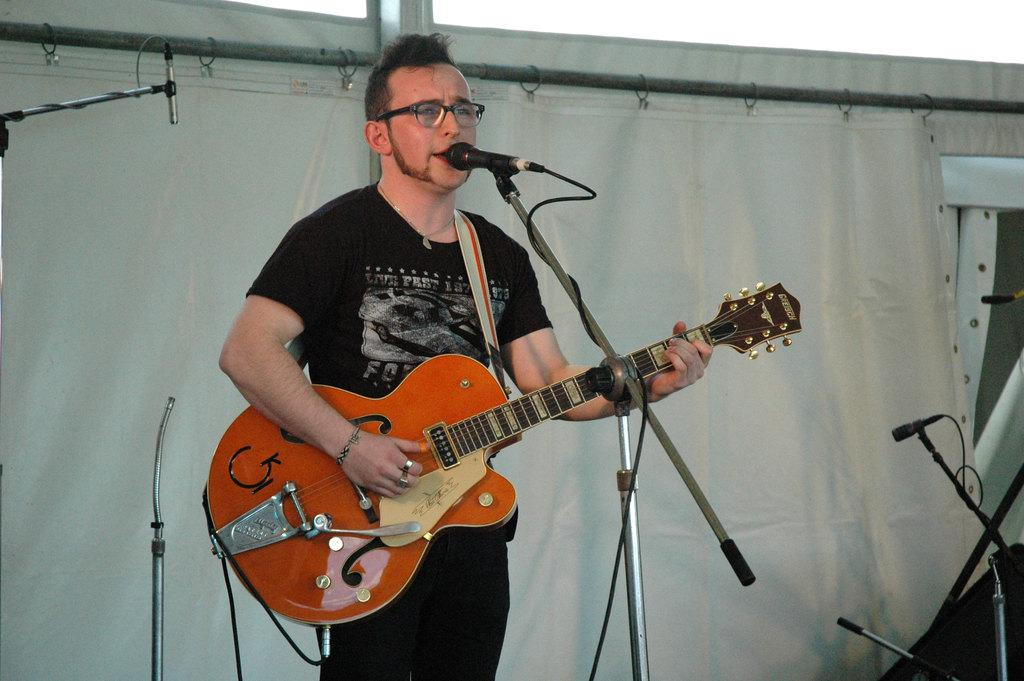What is the person in the image doing? The person is playing a guitar. What is the person wearing in the image? The person is wearing a black color T-shirt. What object is in front of the person? There is a microphone in front of the person. What can be seen in the background of the image? There is a white color curtain in the background. What type of oven is visible in the image? There is no oven present in the image. What role does the governor play in the image? There is no governor present in the image. 